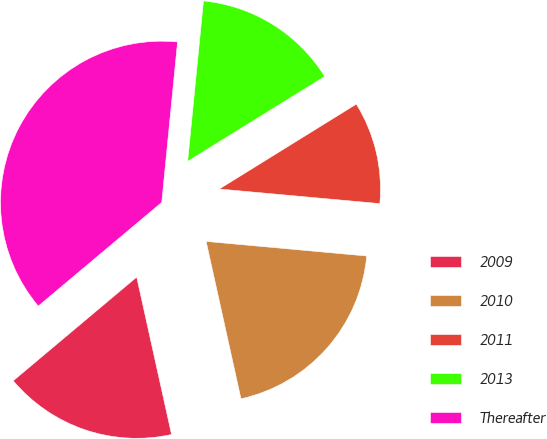<chart> <loc_0><loc_0><loc_500><loc_500><pie_chart><fcel>2009<fcel>2010<fcel>2011<fcel>2013<fcel>Thereafter<nl><fcel>17.35%<fcel>20.09%<fcel>10.27%<fcel>14.61%<fcel>37.68%<nl></chart> 